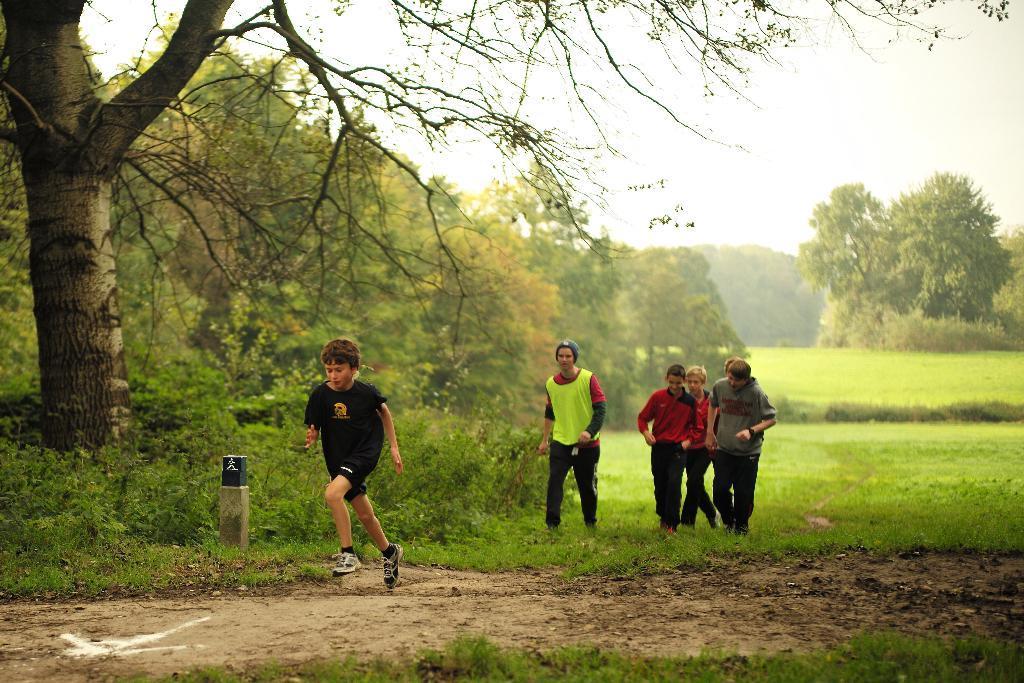How would you summarize this image in a sentence or two? This picture is taken from the outside of the city. In this image, in the middle, we can see a boy wearing a black color shirt is running on the land. In the background, we can see a group of people. In the background, we can see some trees, plants. At the top, we can see a sky, at the bottom, we can see some plants and a grass an a land with some stones. On the left side, we can also see some trees and plants. 